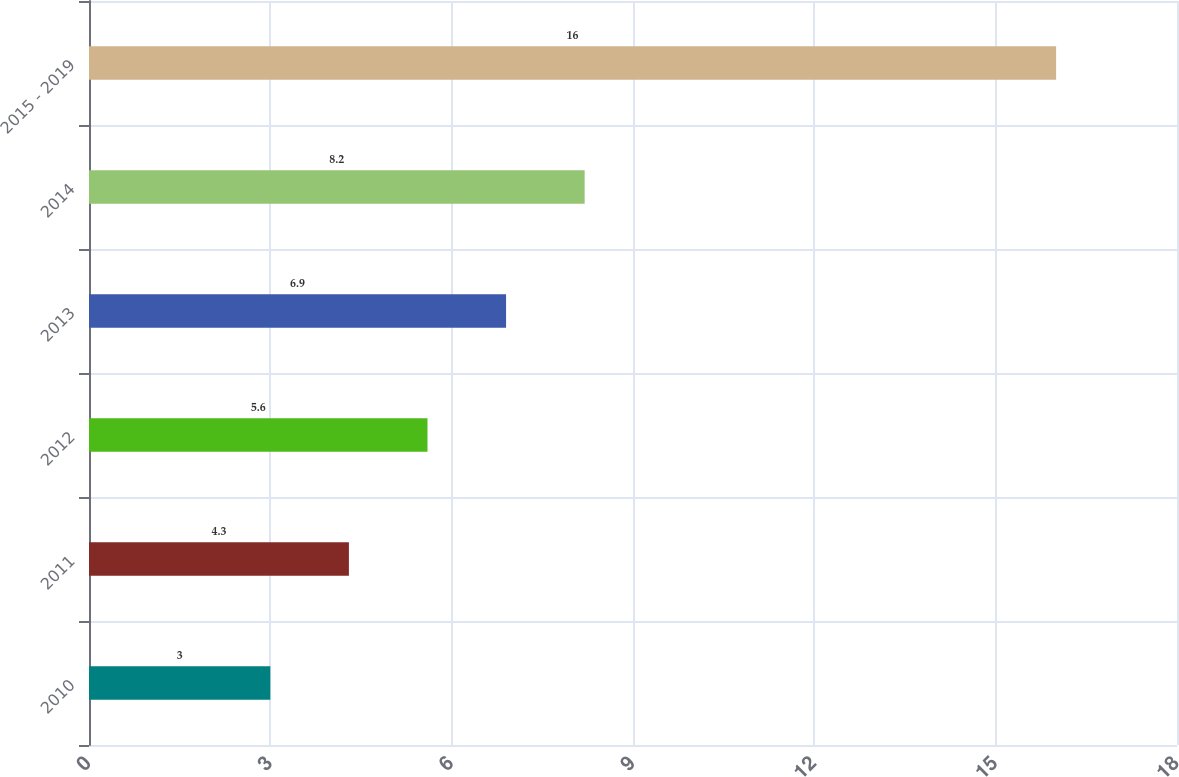<chart> <loc_0><loc_0><loc_500><loc_500><bar_chart><fcel>2010<fcel>2011<fcel>2012<fcel>2013<fcel>2014<fcel>2015 - 2019<nl><fcel>3<fcel>4.3<fcel>5.6<fcel>6.9<fcel>8.2<fcel>16<nl></chart> 